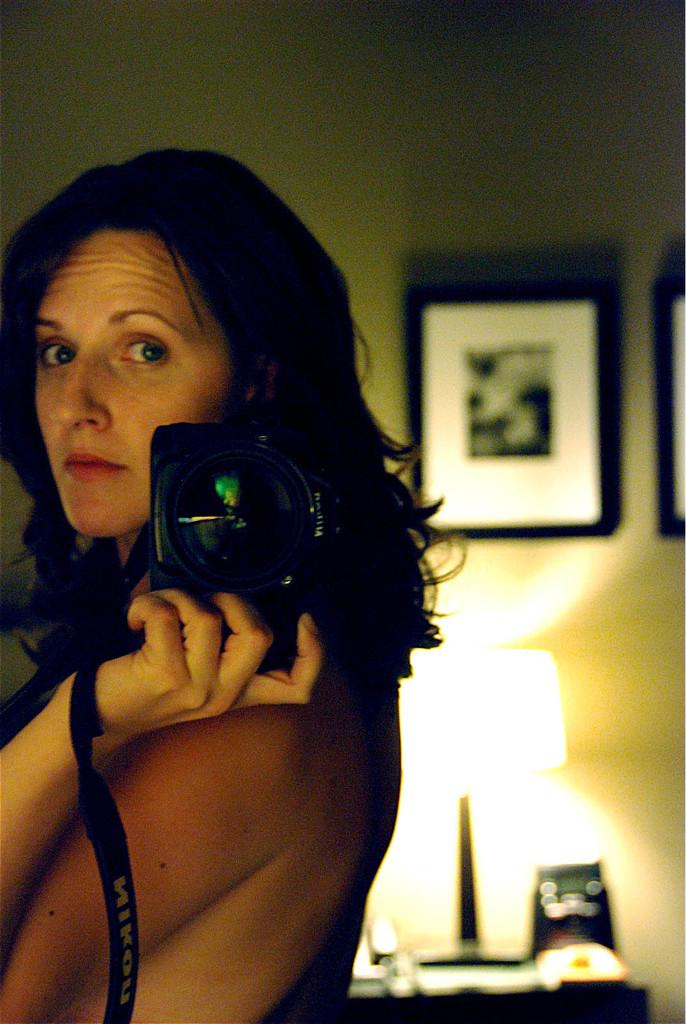What is the main subject of the image? There is a person (she) in the image. What is the person doing in the image? The person is standing. What is the person holding in the image? The person is holding a camera. What can be seen in the background of the image? There is a photo frame and a lamp in the background of the image. What type of territory is the person trying to claim in the image? There is no indication of territory or any claim in the image; it simply shows a person standing and holding a camera. 